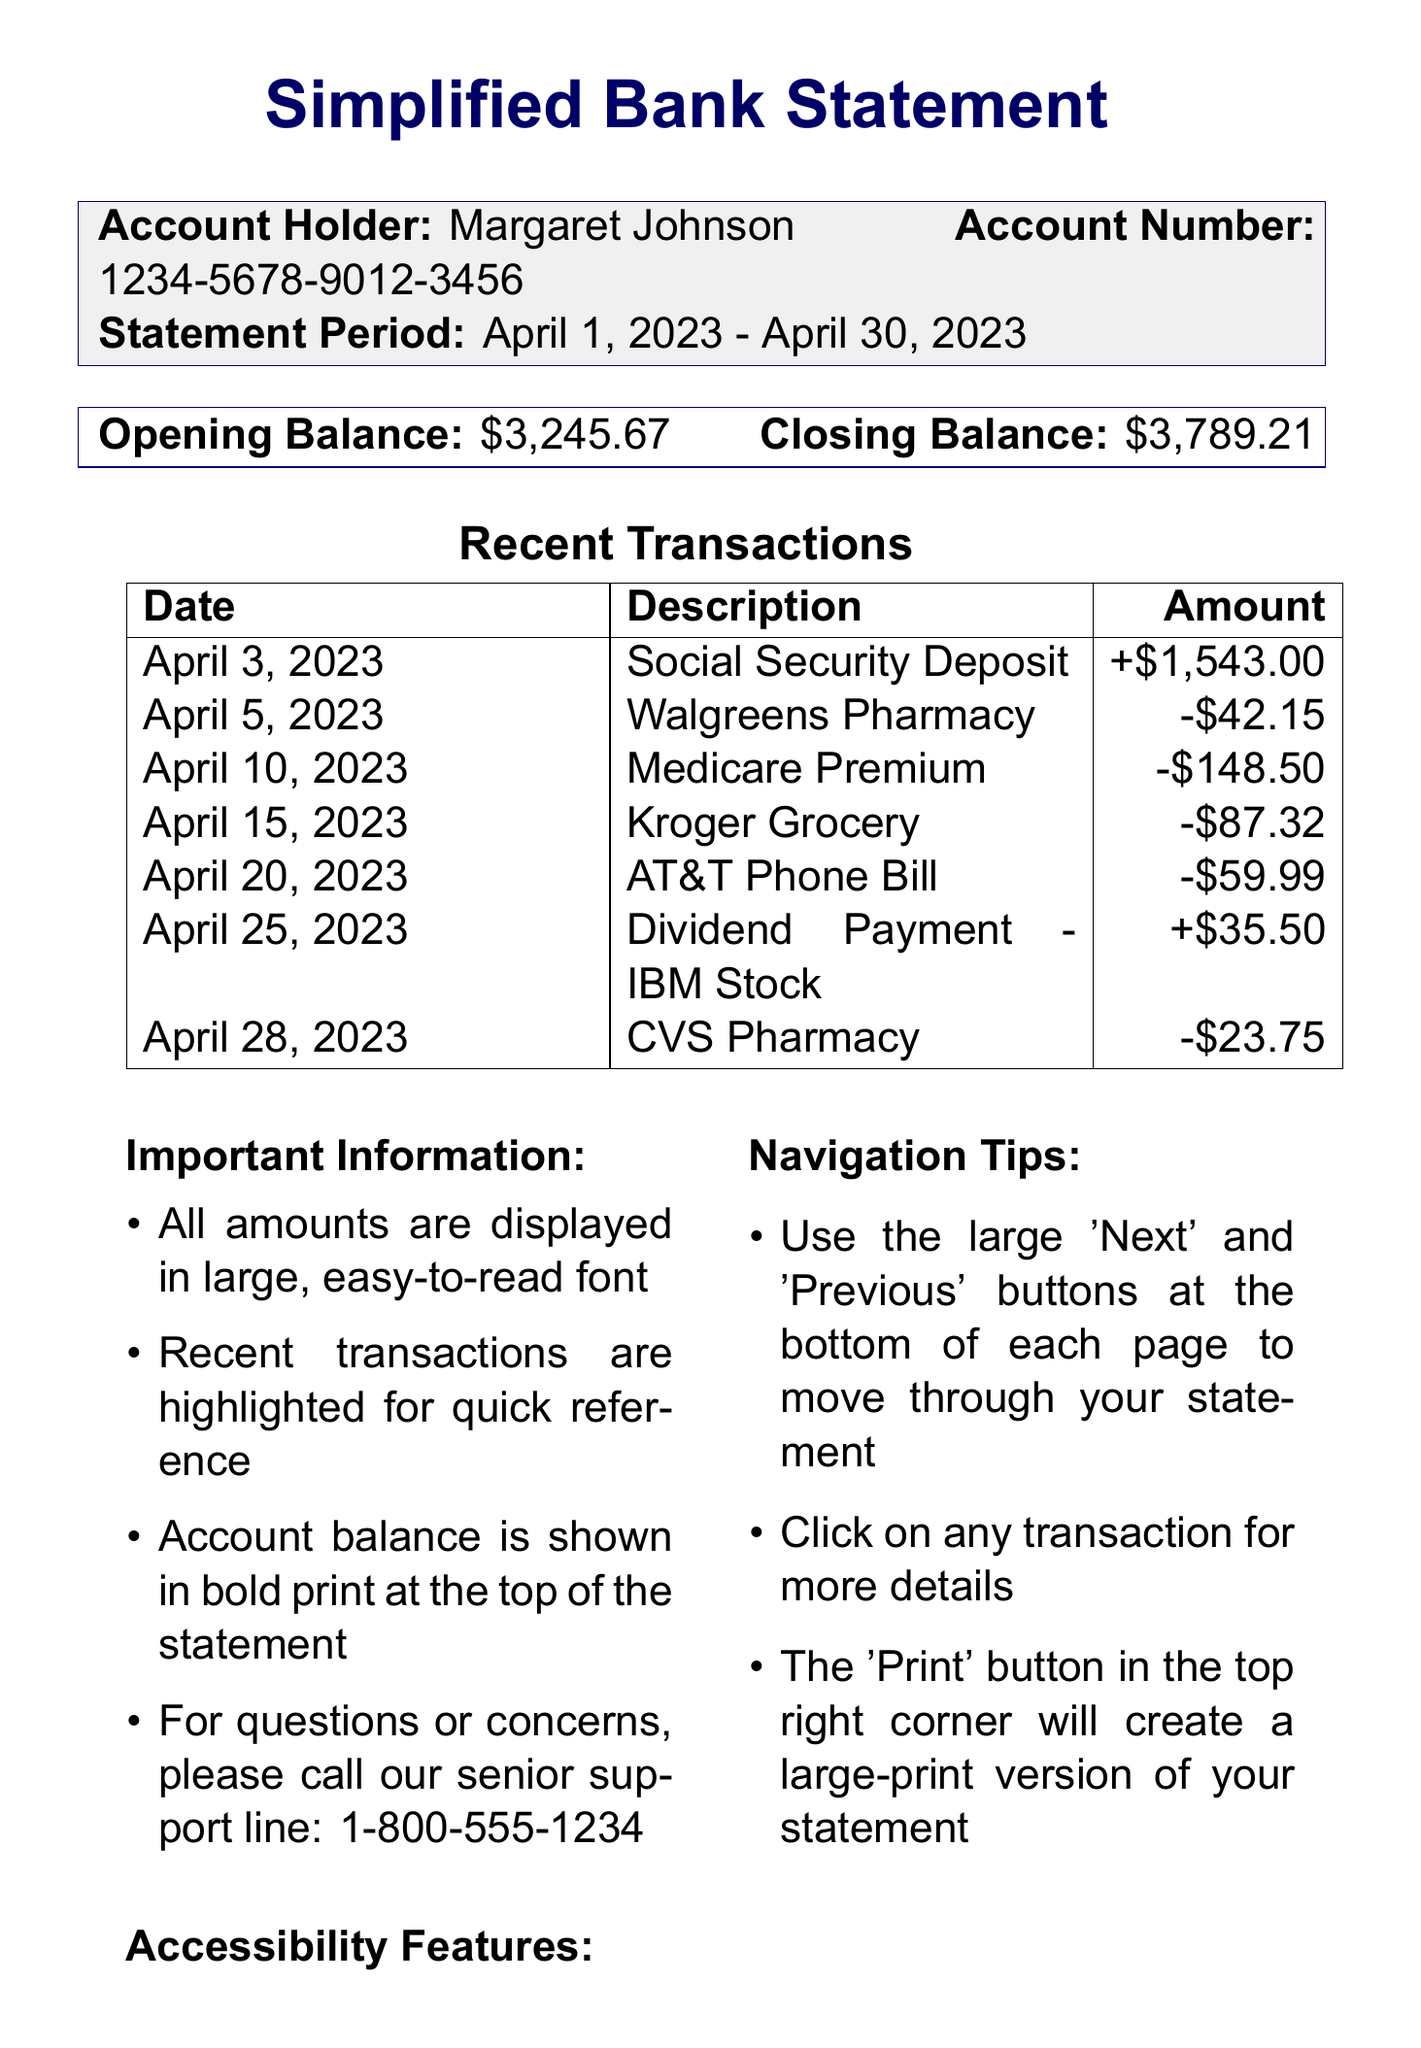What is the account holder's name? The account holder's name is prominently displayed at the top of the statement.
Answer: Margaret Johnson What is the statement period? The statement period indicates the dates covered by the transactions.
Answer: April 1, 2023 - April 30, 2023 What was the opening balance? The opening balance shows the amount at the start of the statement period.
Answer: $3,245.67 What was the closing balance? The closing balance is the final amount at the end of the statement period.
Answer: $3,789.21 What transaction occurred on April 10, 2023? This transaction details a specific activity that took place on this date.
Answer: Medicare Premium How much was deposited from Social Security? The specific amount from the Social Security deposit highlights a source of income.
Answer: +$1,543.00 How many transactions are listed in total? The number of transactions gives an overview of the account activity during the statement period.
Answer: 7 What is the key information regarding transactions? Important information about transactions aids users in understanding document features.
Answer: Recent transactions are highlighted for quick reference What is the phone number for senior support? This number provides assistance for any questions or concerns based on the document.
Answer: 1-800-555-1234 Which feature aids those with vision difficulties? This feature enhances usability for individuals needing assistance while viewing the document.
Answer: High contrast mode for easier viewing 